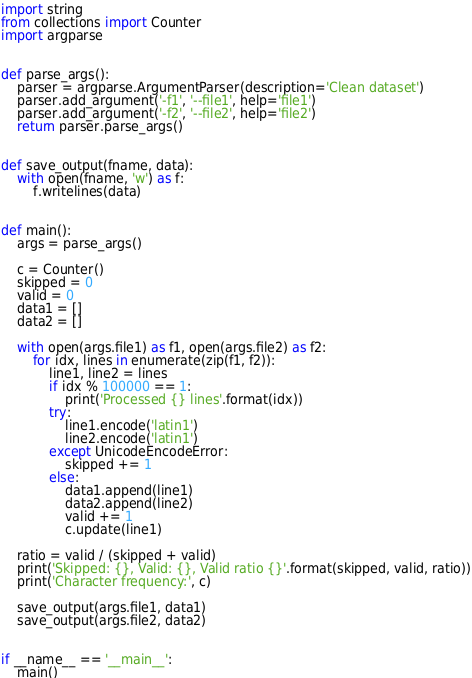Convert code to text. <code><loc_0><loc_0><loc_500><loc_500><_Python_>import string
from collections import Counter
import argparse


def parse_args():
    parser = argparse.ArgumentParser(description='Clean dataset')
    parser.add_argument('-f1', '--file1', help='file1')
    parser.add_argument('-f2', '--file2', help='file2')
    return parser.parse_args()


def save_output(fname, data):
    with open(fname, 'w') as f:
        f.writelines(data)


def main():
    args = parse_args()

    c = Counter()
    skipped = 0
    valid = 0
    data1 = []
    data2 = []

    with open(args.file1) as f1, open(args.file2) as f2:
        for idx, lines in enumerate(zip(f1, f2)):
            line1, line2 = lines
            if idx % 100000 == 1:
                print('Processed {} lines'.format(idx))
            try:
                line1.encode('latin1')
                line2.encode('latin1')
            except UnicodeEncodeError:
                skipped += 1
            else:
                data1.append(line1)
                data2.append(line2)
                valid += 1
                c.update(line1)

    ratio = valid / (skipped + valid)
    print('Skipped: {}, Valid: {}, Valid ratio {}'.format(skipped, valid, ratio))
    print('Character frequency:', c)

    save_output(args.file1, data1)
    save_output(args.file2, data2)


if __name__ == '__main__':
    main()
</code> 